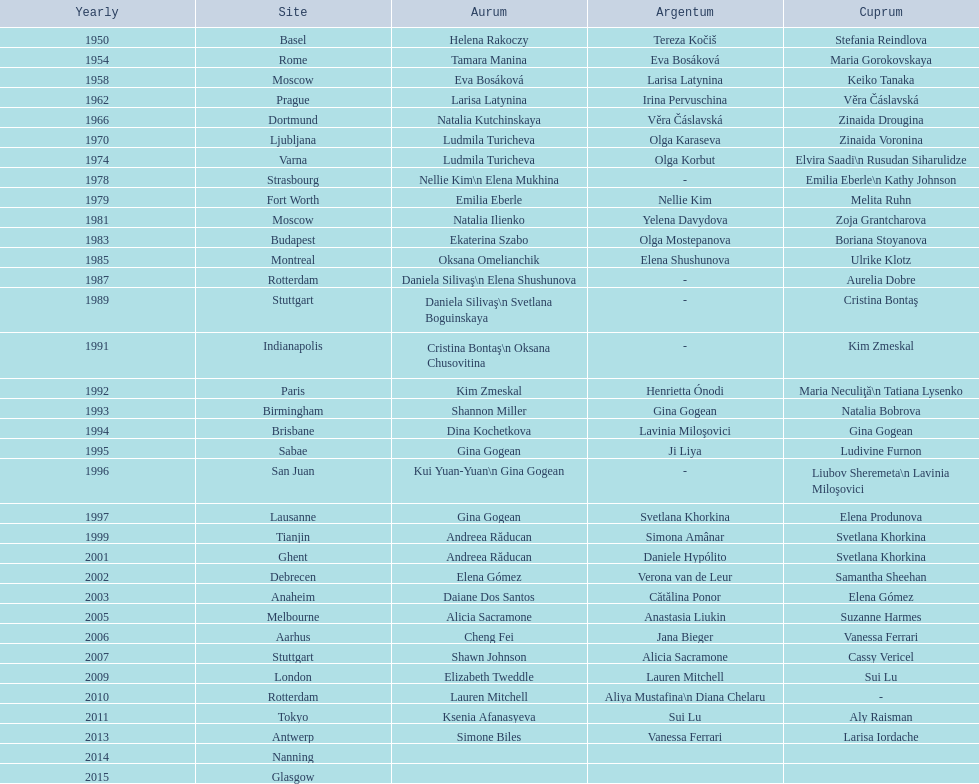Where were the championships held before the 1962 prague championships? Moscow. 